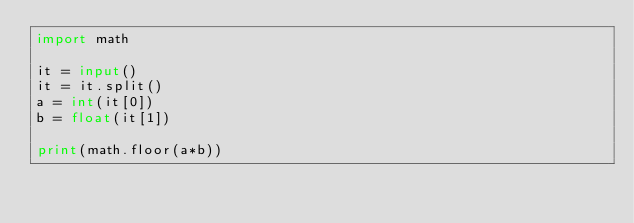<code> <loc_0><loc_0><loc_500><loc_500><_Python_>import math

it = input()
it = it.split()
a = int(it[0])
b = float(it[1])

print(math.floor(a*b))</code> 